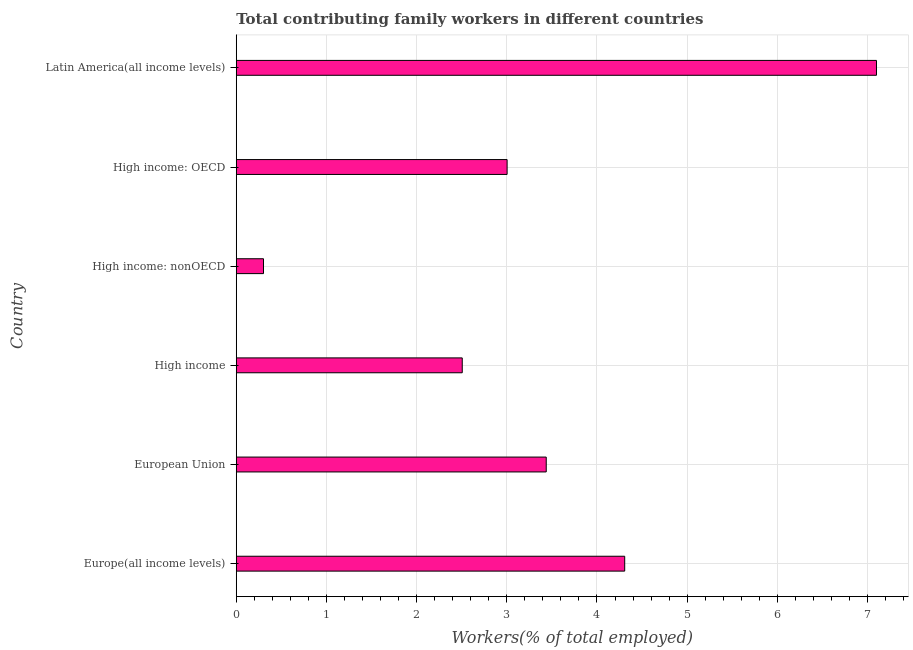Does the graph contain any zero values?
Your answer should be compact. No. What is the title of the graph?
Your response must be concise. Total contributing family workers in different countries. What is the label or title of the X-axis?
Your response must be concise. Workers(% of total employed). What is the contributing family workers in High income?
Give a very brief answer. 2.51. Across all countries, what is the maximum contributing family workers?
Your answer should be compact. 7.1. Across all countries, what is the minimum contributing family workers?
Ensure brevity in your answer.  0.3. In which country was the contributing family workers maximum?
Ensure brevity in your answer.  Latin America(all income levels). In which country was the contributing family workers minimum?
Your response must be concise. High income: nonOECD. What is the sum of the contributing family workers?
Provide a short and direct response. 20.66. What is the difference between the contributing family workers in Europe(all income levels) and Latin America(all income levels)?
Offer a very short reply. -2.79. What is the average contributing family workers per country?
Offer a terse response. 3.44. What is the median contributing family workers?
Your answer should be compact. 3.22. In how many countries, is the contributing family workers greater than 5.8 %?
Ensure brevity in your answer.  1. What is the ratio of the contributing family workers in European Union to that in High income: nonOECD?
Your answer should be compact. 11.38. What is the difference between the highest and the second highest contributing family workers?
Keep it short and to the point. 2.79. Are all the bars in the graph horizontal?
Keep it short and to the point. Yes. What is the difference between two consecutive major ticks on the X-axis?
Provide a short and direct response. 1. What is the Workers(% of total employed) in Europe(all income levels)?
Give a very brief answer. 4.31. What is the Workers(% of total employed) of European Union?
Keep it short and to the point. 3.44. What is the Workers(% of total employed) of High income?
Make the answer very short. 2.51. What is the Workers(% of total employed) in High income: nonOECD?
Ensure brevity in your answer.  0.3. What is the Workers(% of total employed) of High income: OECD?
Keep it short and to the point. 3. What is the Workers(% of total employed) of Latin America(all income levels)?
Your answer should be compact. 7.1. What is the difference between the Workers(% of total employed) in Europe(all income levels) and European Union?
Offer a terse response. 0.87. What is the difference between the Workers(% of total employed) in Europe(all income levels) and High income?
Your answer should be very brief. 1.8. What is the difference between the Workers(% of total employed) in Europe(all income levels) and High income: nonOECD?
Offer a very short reply. 4.01. What is the difference between the Workers(% of total employed) in Europe(all income levels) and High income: OECD?
Ensure brevity in your answer.  1.3. What is the difference between the Workers(% of total employed) in Europe(all income levels) and Latin America(all income levels)?
Offer a very short reply. -2.79. What is the difference between the Workers(% of total employed) in European Union and High income?
Provide a succinct answer. 0.93. What is the difference between the Workers(% of total employed) in European Union and High income: nonOECD?
Keep it short and to the point. 3.14. What is the difference between the Workers(% of total employed) in European Union and High income: OECD?
Offer a terse response. 0.43. What is the difference between the Workers(% of total employed) in European Union and Latin America(all income levels)?
Provide a succinct answer. -3.66. What is the difference between the Workers(% of total employed) in High income and High income: nonOECD?
Provide a short and direct response. 2.2. What is the difference between the Workers(% of total employed) in High income and High income: OECD?
Ensure brevity in your answer.  -0.5. What is the difference between the Workers(% of total employed) in High income and Latin America(all income levels)?
Ensure brevity in your answer.  -4.59. What is the difference between the Workers(% of total employed) in High income: nonOECD and High income: OECD?
Offer a very short reply. -2.7. What is the difference between the Workers(% of total employed) in High income: nonOECD and Latin America(all income levels)?
Your answer should be compact. -6.8. What is the difference between the Workers(% of total employed) in High income: OECD and Latin America(all income levels)?
Offer a very short reply. -4.1. What is the ratio of the Workers(% of total employed) in Europe(all income levels) to that in European Union?
Offer a very short reply. 1.25. What is the ratio of the Workers(% of total employed) in Europe(all income levels) to that in High income?
Keep it short and to the point. 1.72. What is the ratio of the Workers(% of total employed) in Europe(all income levels) to that in High income: nonOECD?
Your answer should be compact. 14.26. What is the ratio of the Workers(% of total employed) in Europe(all income levels) to that in High income: OECD?
Offer a very short reply. 1.43. What is the ratio of the Workers(% of total employed) in Europe(all income levels) to that in Latin America(all income levels)?
Your answer should be compact. 0.61. What is the ratio of the Workers(% of total employed) in European Union to that in High income?
Offer a terse response. 1.37. What is the ratio of the Workers(% of total employed) in European Union to that in High income: nonOECD?
Provide a succinct answer. 11.38. What is the ratio of the Workers(% of total employed) in European Union to that in High income: OECD?
Your response must be concise. 1.14. What is the ratio of the Workers(% of total employed) in European Union to that in Latin America(all income levels)?
Offer a terse response. 0.48. What is the ratio of the Workers(% of total employed) in High income to that in High income: nonOECD?
Provide a succinct answer. 8.29. What is the ratio of the Workers(% of total employed) in High income to that in High income: OECD?
Your response must be concise. 0.83. What is the ratio of the Workers(% of total employed) in High income to that in Latin America(all income levels)?
Your answer should be very brief. 0.35. What is the ratio of the Workers(% of total employed) in High income: nonOECD to that in High income: OECD?
Your response must be concise. 0.1. What is the ratio of the Workers(% of total employed) in High income: nonOECD to that in Latin America(all income levels)?
Keep it short and to the point. 0.04. What is the ratio of the Workers(% of total employed) in High income: OECD to that in Latin America(all income levels)?
Keep it short and to the point. 0.42. 